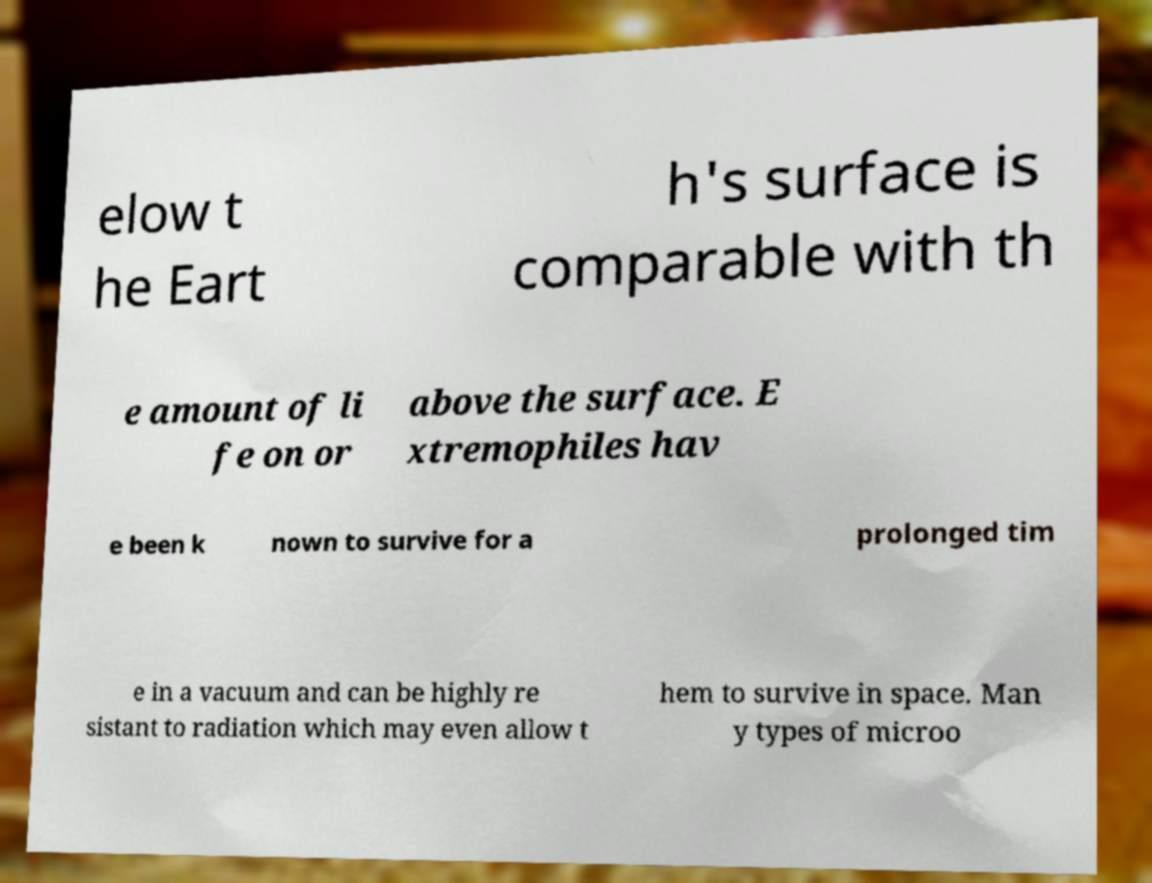For documentation purposes, I need the text within this image transcribed. Could you provide that? elow t he Eart h's surface is comparable with th e amount of li fe on or above the surface. E xtremophiles hav e been k nown to survive for a prolonged tim e in a vacuum and can be highly re sistant to radiation which may even allow t hem to survive in space. Man y types of microo 